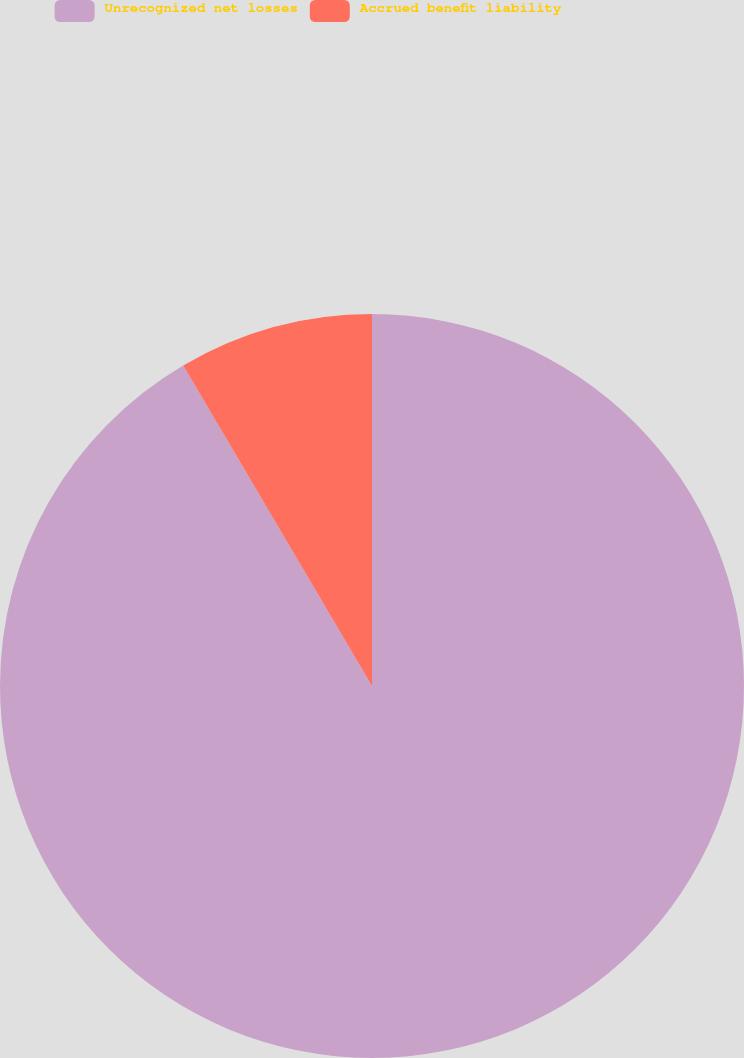Convert chart. <chart><loc_0><loc_0><loc_500><loc_500><pie_chart><fcel>Unrecognized net losses<fcel>Accrued benefit liability<nl><fcel>91.53%<fcel>8.47%<nl></chart> 